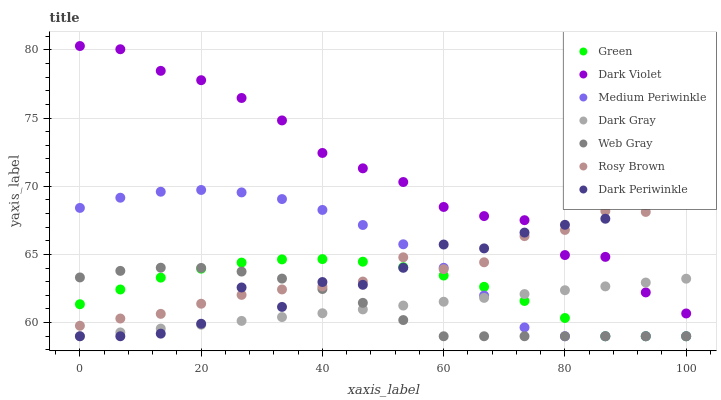Does Dark Gray have the minimum area under the curve?
Answer yes or no. Yes. Does Dark Violet have the maximum area under the curve?
Answer yes or no. Yes. Does Rosy Brown have the minimum area under the curve?
Answer yes or no. No. Does Rosy Brown have the maximum area under the curve?
Answer yes or no. No. Is Dark Gray the smoothest?
Answer yes or no. Yes. Is Dark Periwinkle the roughest?
Answer yes or no. Yes. Is Rosy Brown the smoothest?
Answer yes or no. No. Is Rosy Brown the roughest?
Answer yes or no. No. Does Web Gray have the lowest value?
Answer yes or no. Yes. Does Rosy Brown have the lowest value?
Answer yes or no. No. Does Dark Violet have the highest value?
Answer yes or no. Yes. Does Rosy Brown have the highest value?
Answer yes or no. No. Is Medium Periwinkle less than Dark Violet?
Answer yes or no. Yes. Is Dark Violet greater than Green?
Answer yes or no. Yes. Does Green intersect Web Gray?
Answer yes or no. Yes. Is Green less than Web Gray?
Answer yes or no. No. Is Green greater than Web Gray?
Answer yes or no. No. Does Medium Periwinkle intersect Dark Violet?
Answer yes or no. No. 